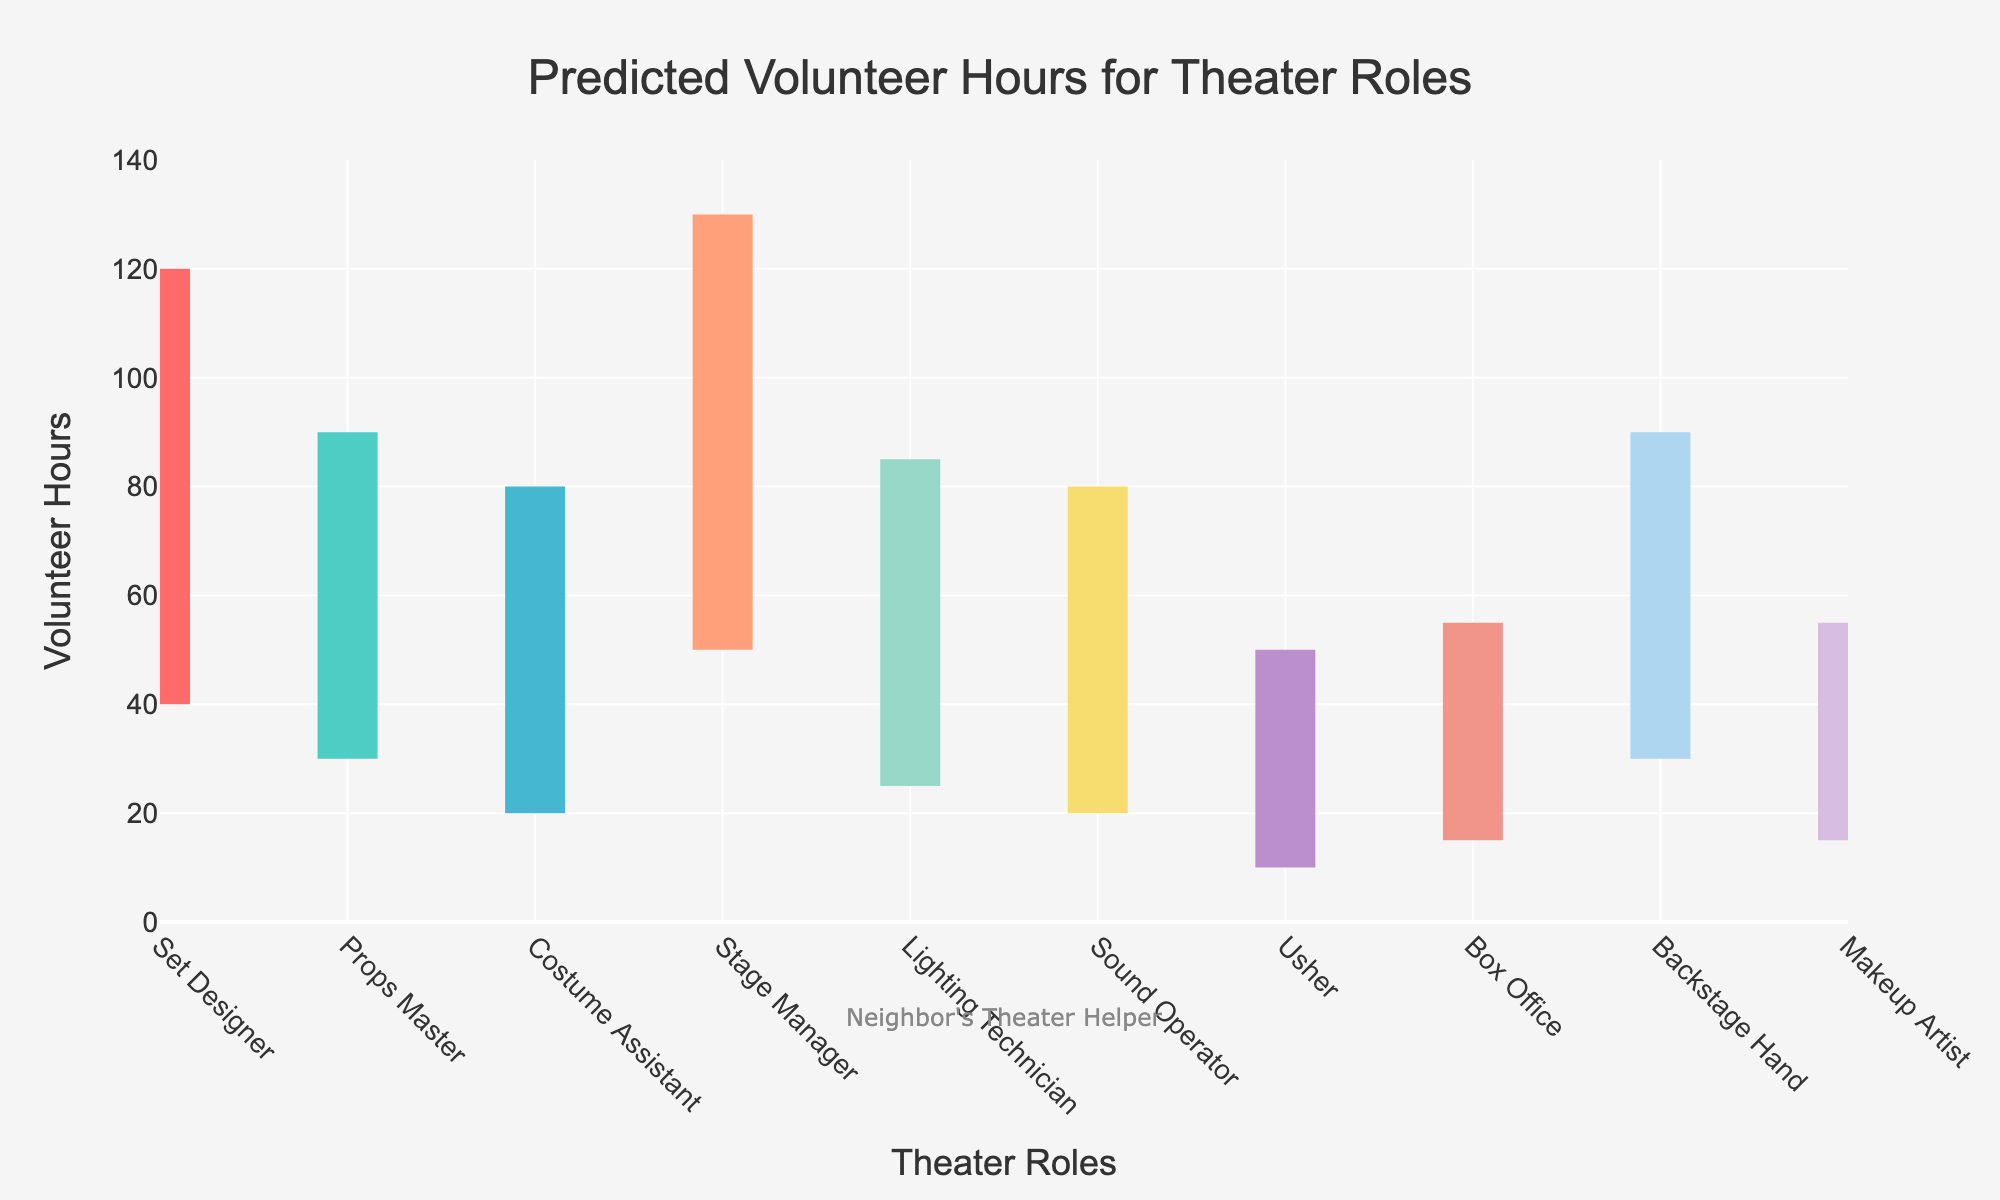How many roles are displayed in the figure? To count the number of roles displayed, look along the x-axis, which lists each role individually. There are 10 roles in total.
Answer: 10 What is the title of the chart? The title is clearly shown at the top of the chart. It reads "Predicted Volunteer Hours for Theater Roles".
Answer: Predicted Volunteer Hours for Theater Roles What is the range of predicted volunteer hours for the Stage Manager role? To determine the range, find the minimum and maximum values for the Stage Manager role. The values are 50 (Min) and 130 (Max). The range is calculated as 130 - 50 = 80.
Answer: 80 Which role has the lowest minimum predicted volunteer hours? By comparing the 'Min' values of each role, Usher has the lowest minimum predicted volunteer hours at 10.
Answer: Usher Is the median predicted volunteer hours for Props Master higher or lower than for Costume Assistant? Compare the median volunteer hours for each role. Props Master has a median of 60 hours, while Costume Assistant has a median of 50 hours. Therefore, Props Master's median is higher.
Answer: Higher What's the average of the maximum predicted volunteer hours for the Set Designer and Backstage Hand roles? The maximum predicted volunteer hours are 120 for Set Designer and 90 for Backstage Hand. Average = (120 + 90) / 2 = 210 / 2 = 105.
Answer: 105 Between Lighting Technician and Sound Operator, which role has a wider range of predicted volunteer hours? Calculate the range for each role. For Lighting Technician, the range is 85 - 25 = 60. For Sound Operator, the range is 80 - 20 = 60. Both have the same width of 60.
Answer: Same What color represents the Costume Assistant role on the chart? Observing the color associated with the Costume Assistant role, it's represented by light blue.
Answer: Light blue How many roles have their highest predicted volunteer hours (Max) greater than 100? Identify the roles with maximum values over 100 hours: Set Designer (120), Stage Manager (130). So, there are 2 roles.
Answer: 2 What is the difference between the maximum predicted volunteer hours of Makeup Artist and Box Office roles? For Makeup Artist, the maximum prediction is 55 hours. For Box Office, it is 55 hours as well. The difference is 55 - 55 = 0.
Answer: 0 